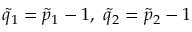<formula> <loc_0><loc_0><loc_500><loc_500>{ \tilde { q } } _ { 1 } = { \tilde { p } } _ { 1 } - 1 , { \tilde { q } } _ { 2 } = { \tilde { p } } _ { 2 } - 1</formula> 